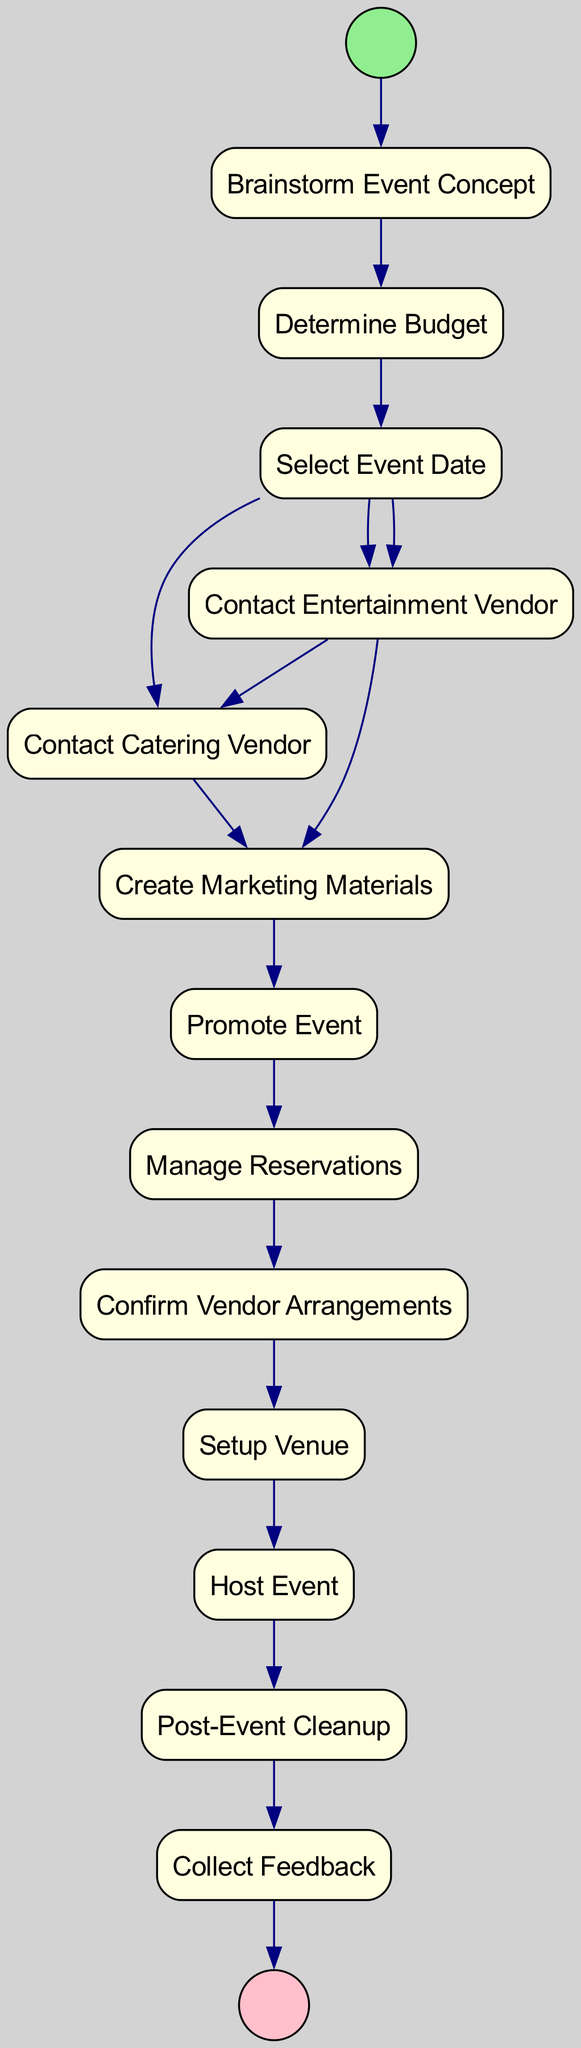What is the first activity in the diagram? The first activity after the start node is "Brainstorm Event Concept". As the start node directs to the first activity in the flow, it identifies "Brainstorm Event Concept" as the initial stage in organizing the event.
Answer: Brainstorm Event Concept How many main activities are shown in the diagram? The diagram lists 12 activities (including "Brainstorm Event Concept" and ending with "Collect Feedback"). Counting each labeled rectangle in the sequence provides the total number of activities outlined.
Answer: 12 What occurs immediately after determining the budget? The next node that follows "Determine Budget" is "Select Event Date". A direct edge connects these two activities in the flow, indicating this sequential progression in event planning.
Answer: Select Event Date Which activity involves vendors? The activities "Contact Entertainment Vendor" and "Contact Catering Vendor" both involve vendors. These two activities are specifically focused on reaching out to vendors as part of the event organization process.
Answer: Contact Entertainment Vendor, Contact Catering Vendor How is the promotion of the event initiated? The promotion process starts after the "Create Marketing Materials" activity is completed. The edge indicates that "Promote Event" directly follows from "Create Marketing Materials", showcasing a clear connection in the planning timeline.
Answer: Promote Event What activity follows the event being hosted? After "Host Event", the subsequent activity in the diagram is "Post-Event Cleanup". The flow structure leads from hosting the event to managing the follow-up cleanup tasks.
Answer: Post-Event Cleanup Which two activities join together before promoting the event? The activities "Contact Entertainment Vendor" and "Contact Catering Vendor" both converge at the "Create Marketing Materials" node, indicating collaboration or parallel processes that lead into promotion.
Answer: Contact Entertainment Vendor, Contact Catering Vendor What is the final step after hosting the event? The last action in the flow after hosting is "Collect Feedback". This stage comes purposefully at the end of the entire event process, ensuring that feedback is gathered to improve future events.
Answer: Collect Feedback 